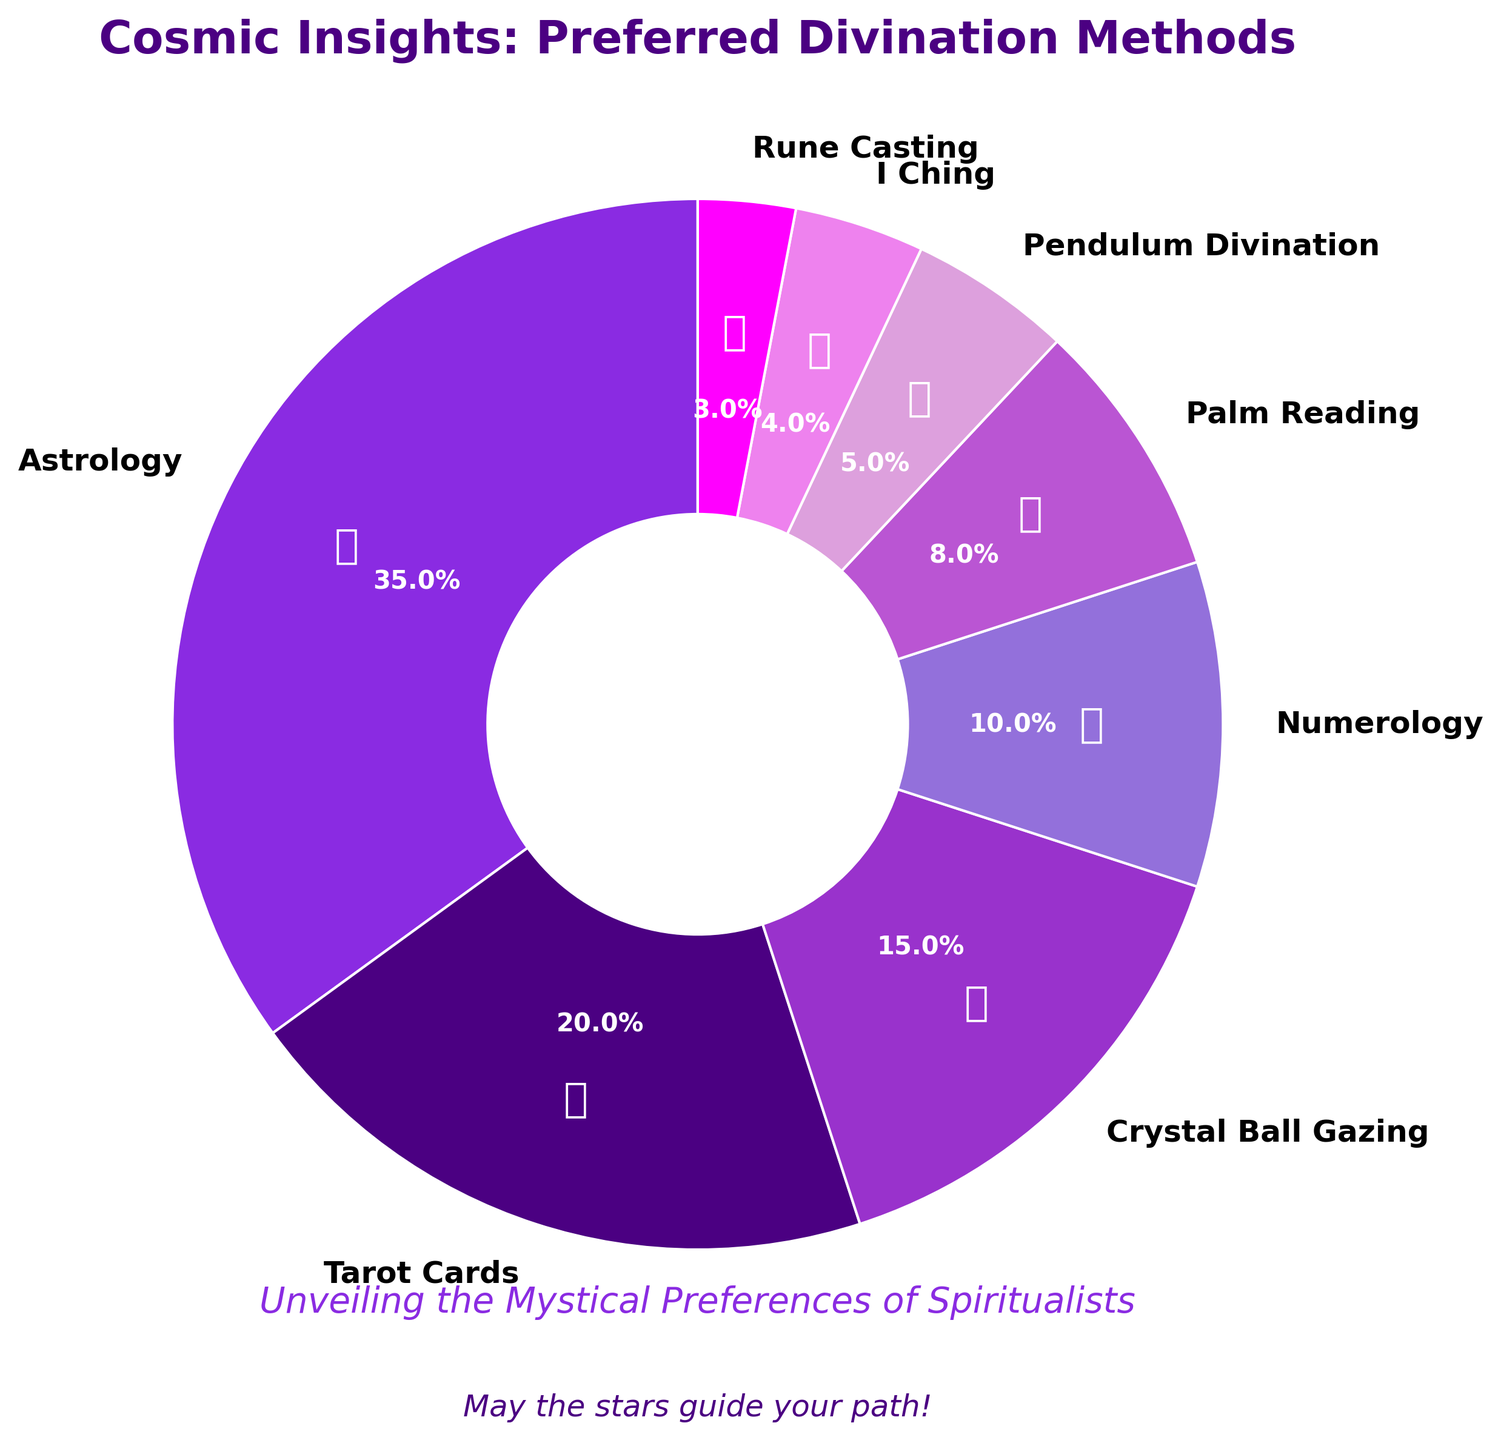What's the most preferred divination method among spiritualists? The pie chart shows that Astrology has the largest slice with a percentage of 35, making it the most preferred divination method among spiritualists.
Answer: Astrology How much more preferred is Tarot Cards compared to Pendulum Divination? Tarot Cards have a preference percentage of 20, while Pendulum Divination has 5. The difference is calculated as 20 - 5 = 15.
Answer: 15 If you combine the preferences for Crystal Ball Gazing, Numerology, and Palm Reading, what percentage do you get? Crystal Ball Gazing has 15%, Numerology has 10%, and Palm Reading has 8%. Summing these up: 15 + 10 + 8 = 33%.
Answer: 33% Which divination method has the least preference among spiritualists? The pie chart shows that Rune Casting has the smallest slice with a percentage of 3, making it the least preferred method.
Answer: Rune Casting Is the combined percentage for Tarot Cards and Crystal Ball Gazing more than 50%? The percentage for Tarot Cards is 20% and for Crystal Ball Gazing is 15%. Adding these gives 20 + 15 = 35%, which is less than 50%.
Answer: No What is the total percentage represented by Numerology, Palm Reading, and I Ching combined? Numerology is 10%, Palm Reading is 8%, and I Ching is 4%. Adding these gives 10 + 8 + 4 = 22%.
Answer: 22% Which divination methods have a preference percentage greater than 10%? The methods with a preference percentage greater than 10% are Astrology (35%), Tarot Cards (20%), and Crystal Ball Gazing (15%).
Answer: Astrology, Tarot Cards, Crystal Ball Gazing If you remove Astrology's percentage from the total, what percentage of the pie chart do the other methods cover? The total percentage is 100%. Removing Astrology's 35% leaves 100 - 35 = 65%.
Answer: 65% What percentage of spiritualists prefer methods other than Astrology or Tarot Cards? The percentage for Astrology is 35% and for Tarot Cards is 20%. Combined, they are 35 + 20 = 55%. The remaining methods cover 100 - 55 = 45%.
Answer: 45% Is the preference for Palm Reading closer to Pendulum Divination or Crystal Ball Gazing? Palm Reading is 8%, Pendulum Divination is 5%, and Crystal Ball Gazing is 15%. The differences are 8 - 5 = 3 (closer to Pendulum Divination) and 15 - 8 = 7 (further from Crystal Ball Gazing).
Answer: Pendulum Divination 